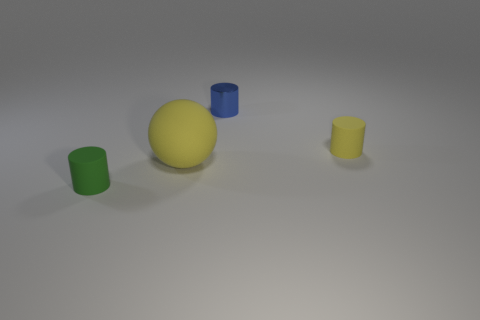Add 2 big green cylinders. How many objects exist? 6 Subtract all cylinders. How many objects are left? 1 Add 1 large green matte balls. How many large green matte balls exist? 1 Subtract 1 yellow spheres. How many objects are left? 3 Subtract all metal objects. Subtract all yellow things. How many objects are left? 1 Add 3 small rubber objects. How many small rubber objects are left? 5 